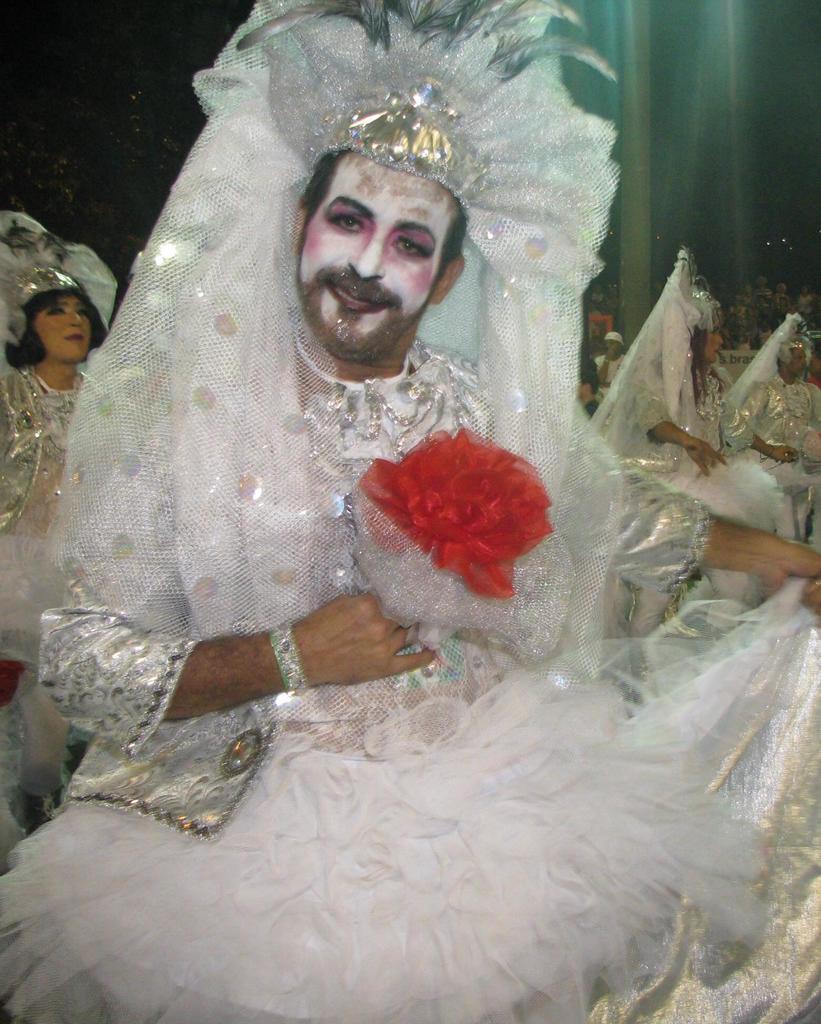Could you give a brief overview of what you see in this image? In the foreground of this picture we can see a man wearing a crown, white color frock and holding some object and seems to be dancing. In the background we can see the group of persons wearing white color dresses and seems to be done dancing and we can the group of persons and some other objects. 